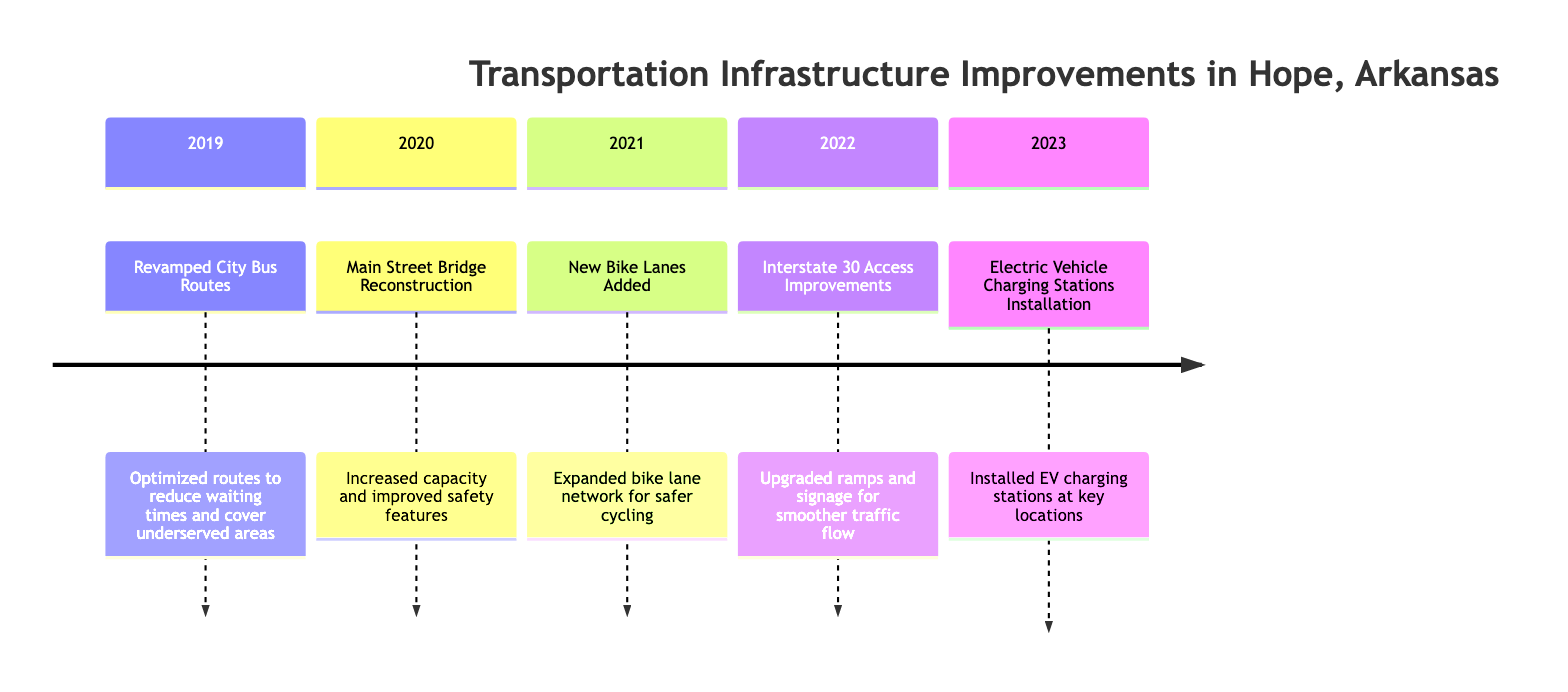What was the first transportation improvement in Hope? The diagram shows that the first improvement listed in the timeline occurs in 2019, which is the revamped city bus routes.
Answer: Revamped City Bus Routes How many transportation infrastructure improvements occurred in 2021? The diagram indicates that there was one improvement noted in 2021, which is the addition of new bike lanes.
Answer: 1 Which year saw the installation of Electric Vehicle Charging Stations? By examining the timeline, it is clear that the installation of Electric Vehicle Charging Stations happened in 2023.
Answer: 2023 What type of improvement was made to Main Street in 2020? The diagram specifies that in 2020, the improvement made to Main Street was the reconstruction of the bridge, which included increased capacity and improved safety features.
Answer: Bridge Reconstruction What transportation improvement connects directly to Interstate 30? The diagram shows that the access improvements related to Interstate 30 occurred in 2022, indicating a connection to this major roadway.
Answer: Access Improvements How has the city bus service changed from 2019 to 2020? In 2019, the city bus routes were revamped, and in 2020, the Main Street bridge was reconstructed, which indicates a shift from public transportation improvements to infrastructure development for roadway safety and capacity.
Answer: Shift in focus Which year has the most recent improvement listed? The diagram lists improvements chronologically, with the most recent improvement occurring in 2023, which involves the installation of Electric Vehicle Charging Stations.
Answer: 2023 What safety aspect was specifically improved in the bridge reconstruction? The diagram notes that the bridge reconstruction in 2020 included improved safety features, indicating the focus on enhancing the safety of the structure.
Answer: Safety features How does the bike lane addition in 2021 contribute to transportation infrastructure? The addition of new bike lanes in 2021 is aimed at expanding the bike lane network for safer cycling, which contributes to promoting alternative transportation options and improving safety for cyclists.
Answer: Safer cycling 